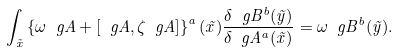Convert formula to latex. <formula><loc_0><loc_0><loc_500><loc_500>\int _ { \vec { x } } \left \{ \omega \ g A + [ \ g A , \zeta \ g A ] \right \} ^ { a } ( \vec { x } ) \frac { \delta \ g B ^ { b } ( \vec { y } ) } { \delta \ g A ^ { a } ( \vec { x } ) } = \omega \ g B ^ { b } ( \vec { y } ) .</formula> 